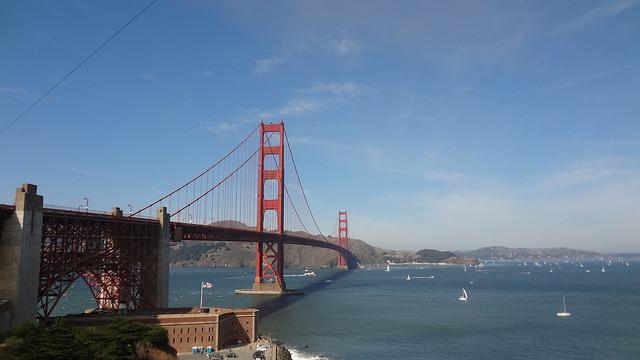What state is this in?
Answer briefly. California. How many people are on the bridge?
Quick response, please. 0. Was it taken in the USA?
Short answer required. Yes. Are there boats in the picture?
Keep it brief. Yes. Is this in a foreign country?
Quick response, please. No. Is this a bridge for automobiles?
Concise answer only. Yes. Could this be the River Thames?
Short answer required. No. Where is the bridge?
Keep it brief. San francisco. Could large semi trucks cross this bridge?
Write a very short answer. Yes. Is this scene in the mountains?
Short answer required. No. Are there boats on the water?
Keep it brief. Yes. What time of day is this?
Write a very short answer. Afternoon. Was this picture taken in the US?
Keep it brief. Yes. Could this be a parade float?
Answer briefly. No. Where is the bridge located?
Keep it brief. San francisco. What is this iconic bridges name?
Keep it brief. Golden gate. Is the water muddy?
Write a very short answer. No. 